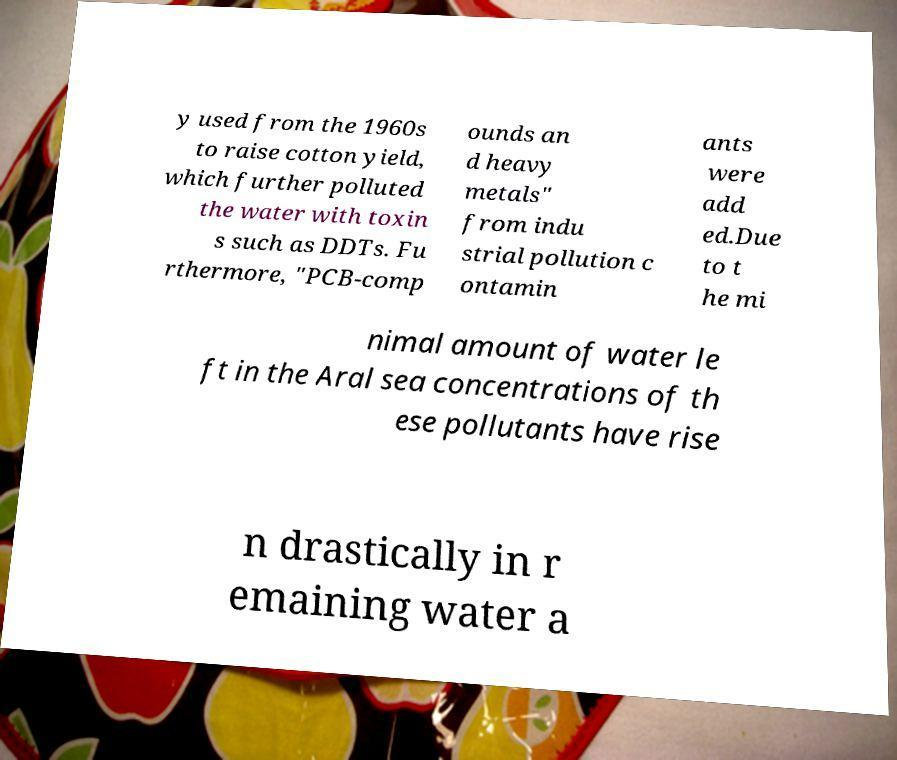For documentation purposes, I need the text within this image transcribed. Could you provide that? y used from the 1960s to raise cotton yield, which further polluted the water with toxin s such as DDTs. Fu rthermore, "PCB-comp ounds an d heavy metals" from indu strial pollution c ontamin ants were add ed.Due to t he mi nimal amount of water le ft in the Aral sea concentrations of th ese pollutants have rise n drastically in r emaining water a 